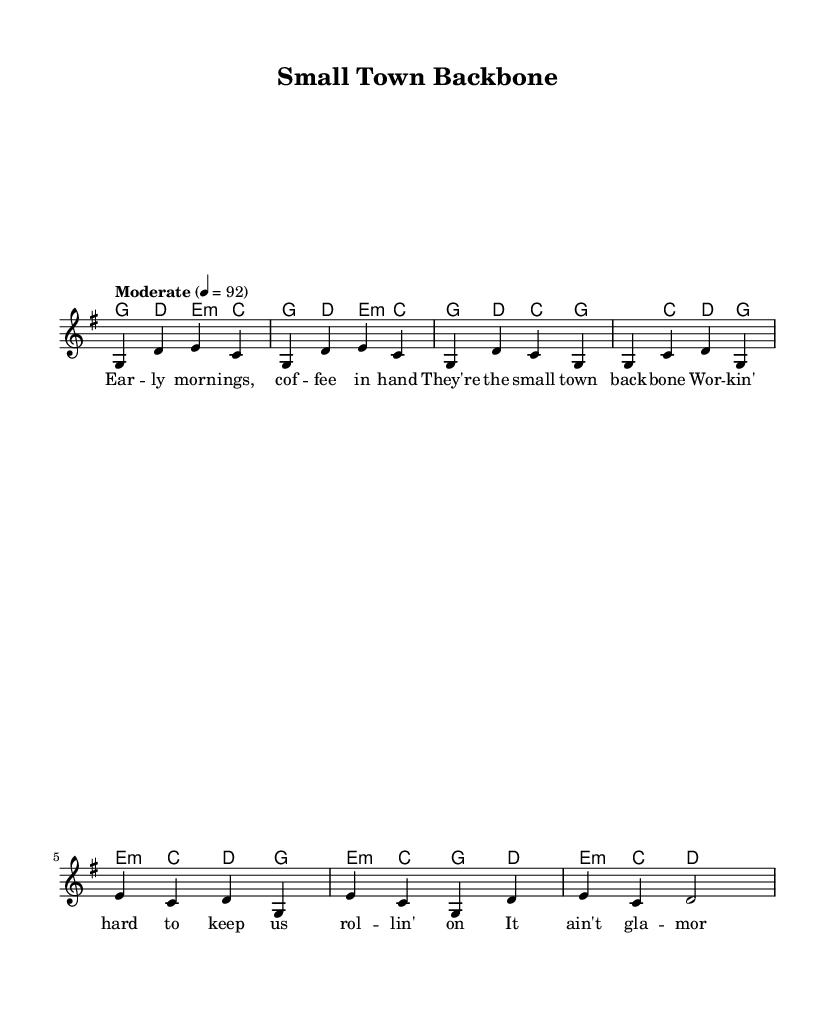What is the key signature of this piece? The key signature is indicated at the beginning of the score, showing one sharp (F#) which denotes G major.
Answer: G major What is the time signature of this music? The time signature is found at the beginning of the sheet music, represented by a '4/4' symbol which indicates there are four beats per measure and the quarter note receives one beat.
Answer: 4/4 What is the tempo marking for this piece? The tempo marking is specified at the start of the score as "Moderate" with a metronome indication of 92 beats per minute which provides a speed for performing the music.
Answer: Moderate 92 How many parts are included in the score? By examining the score, we see three distinct parts: the chord names, the melody, and the lyrics.
Answer: Three What is the function of the bridge section in this song? The bridge section contrasts with the verses and chorus; it typically serves as a transition or provides a change in perspective within the song's narrative. Here, it adds depth to the celebration of everyday heroes.
Answer: Transition What is the primary theme of the lyrics in this anthem? By analyzing the lyrics presented, the central theme emphasizes gratitude towards local heroes, specifically those who work hard in small towns, establishing a narrative of appreciation and recognition.
Answer: Everyday heroes What chord starts the chorus of the piece? The first chord of the chorus is indicated on the sheet music where the melody begins. Here, it begins with a G major chord followed by C and D in the chorus section.
Answer: G major 